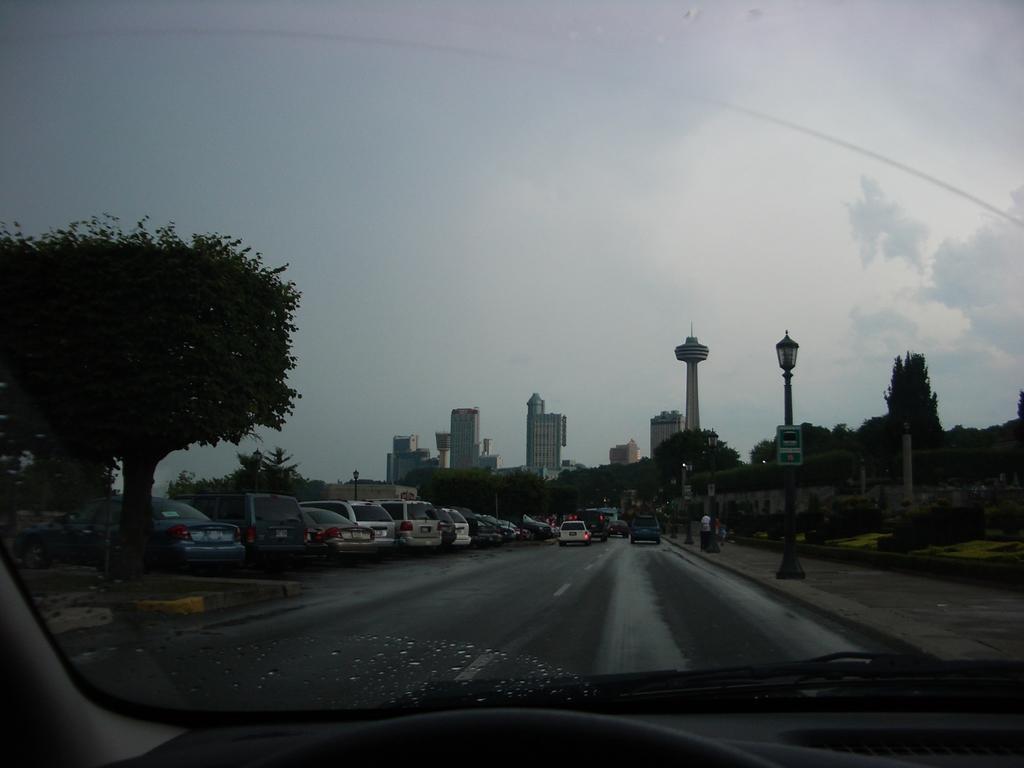In one or two sentences, can you explain what this image depicts? To the bottom of the image there is a car. The image is taken from inside the car. Outside the car glass on the road there are many vehicles to the left side of the image. And in the middle of the image there are few cars are on the road. And to the right side of the image there is a footpath with poles and lamps. In the background there are many trees and buildings. To the top of the image there is a sky. 